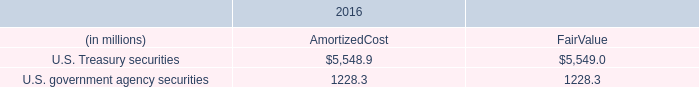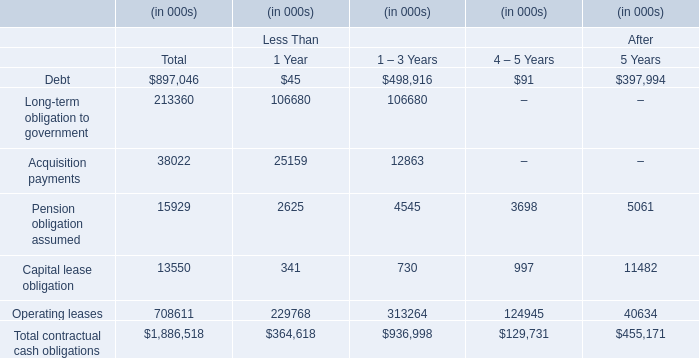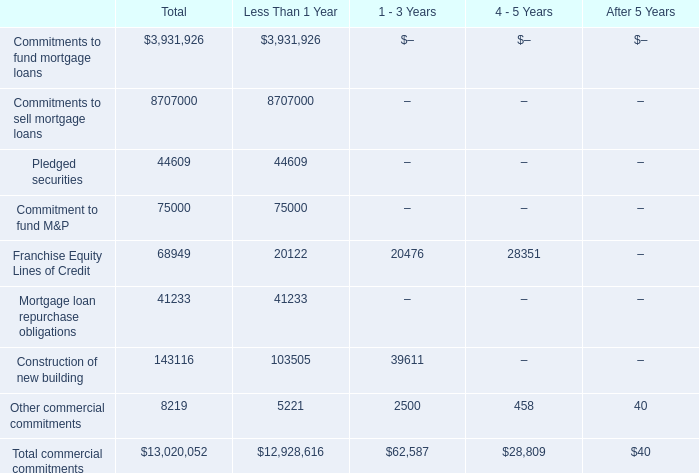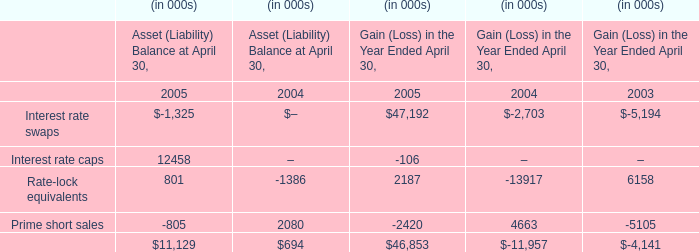In the section with largest amount ofFranchise Equity Lines of Credit , what's the sum of Other commercial commitments and Total commercial commitments ? 
Computations: (2500 + 62587)
Answer: 65087.0. 